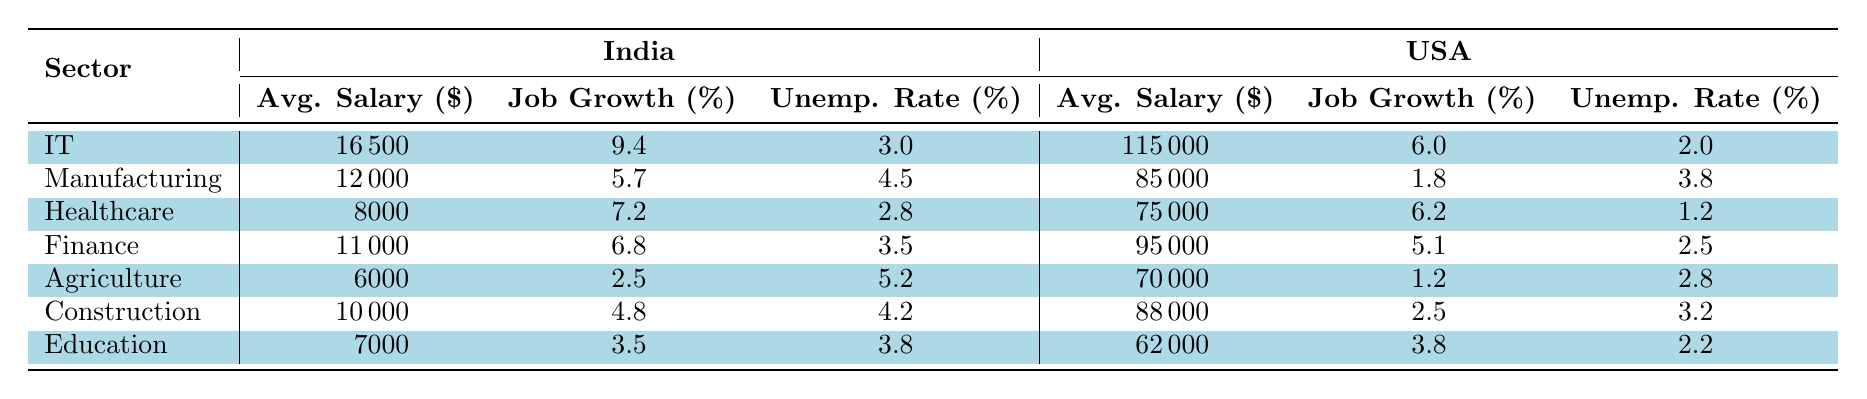What is the average salary for IT jobs in India? The average salary for IT jobs in India is listed in the table under the India column for the IT sector. It shows that the average salary is 16500 dollars.
Answer: 16500 What is the job growth percentage for the Healthcare sector in the USA? The job growth percentage for the Healthcare sector in the USA can be found in the USA column for Healthcare in the table. It lists the job growth as 6.2%.
Answer: 6.2 Is the unemployment rate for Manufacturing higher in India than in the USA? To find the unemployment rates for Manufacturing, we look at the table. India has an unemployment rate of 4.5% while the USA has 3.8%. Since 4.5% is greater than 3.8%, the statement is true.
Answer: Yes What is the difference in average salary between the Construction sectors of India and the USA? The average salary for Construction jobs in India is 10000 and in the USA it is 88000. The difference is calculated by subtracting the Indian salary from the American salary: 88000 - 10000 = 78000.
Answer: 78000 Which sector has the highest job growth in India? By comparing the job growth percentages listed in the table for all sectors in India, we see that the IT sector has the highest at 9.4%.
Answer: IT Which country has a lower average salary in Healthcare: India or the USA? Referring to the average salaries in the Healthcare sector, India has an average salary of 8000 while the USA has 75000. Since 8000 is less than 75000, India has the lower salary.
Answer: India What is the average unemployment rate for the Finance sector in both countries? The unemployment rate for Finance in India is 3.5% and in the USA, it is 2.5%. To find the average, we sum these rates (3.5 + 2.5) and divide by 2: (3.5 + 2.5) / 2 = 3.0%.
Answer: 3.0 In which sector does the USA have a higher average salary, IT or Agriculture? Checking the average salaries for both sectors, in IT, the USA has an average salary of 115000 and in Agriculture, it is 70000. Since 115000 is greater than 70000, the USA has a higher salary in IT.
Answer: IT Is the job growth percentage in the Agriculture sector for India greater than that for the USA? The job growth percentage for Agriculture in India is listed as 2.5%, while in the USA it is 1.2%. Since 2.5% is greater than 1.2%, the statement is true.
Answer: Yes 